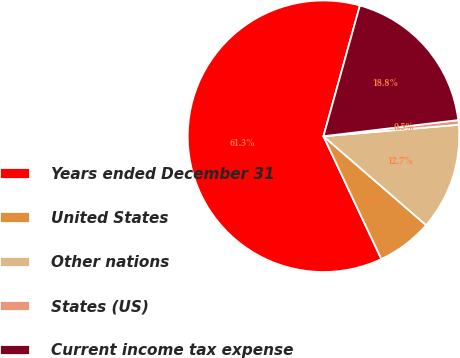<chart> <loc_0><loc_0><loc_500><loc_500><pie_chart><fcel>Years ended December 31<fcel>United States<fcel>Other nations<fcel>States (US)<fcel>Current income tax expense<nl><fcel>61.34%<fcel>6.63%<fcel>12.71%<fcel>0.55%<fcel>18.78%<nl></chart> 